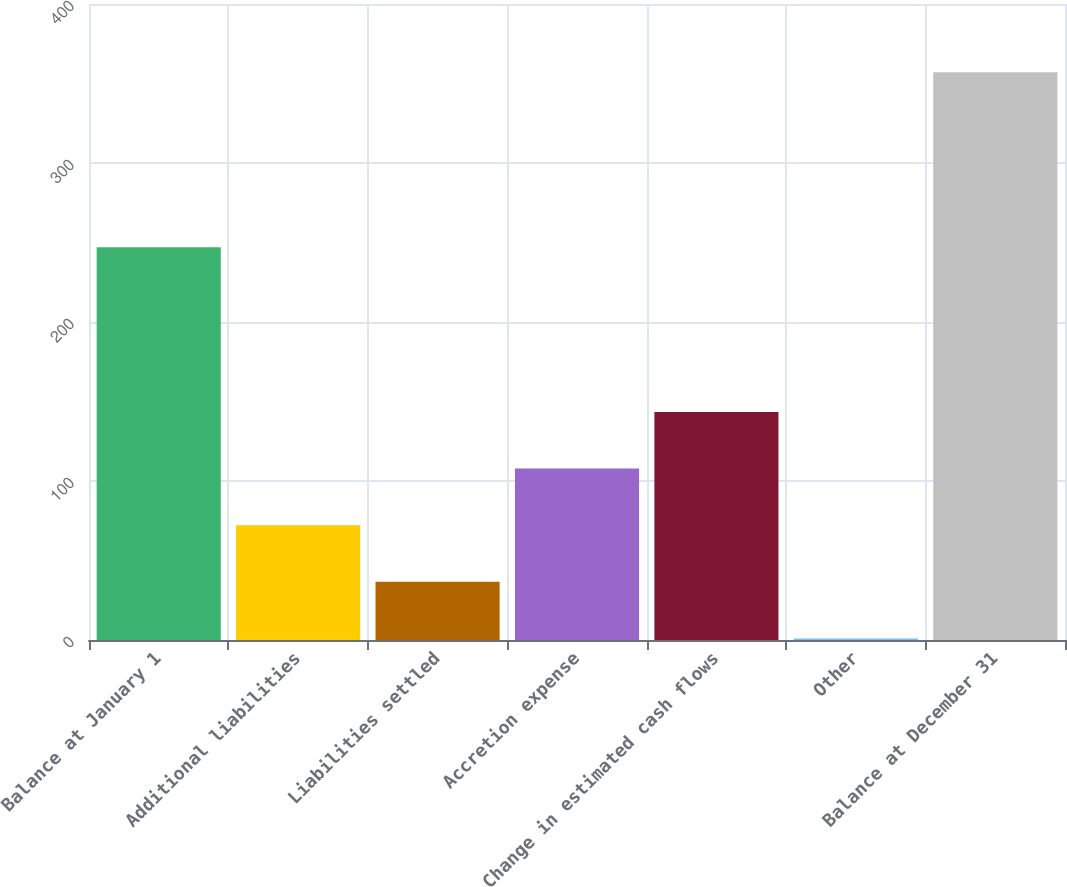Convert chart. <chart><loc_0><loc_0><loc_500><loc_500><bar_chart><fcel>Balance at January 1<fcel>Additional liabilities<fcel>Liabilities settled<fcel>Accretion expense<fcel>Change in estimated cash flows<fcel>Other<fcel>Balance at December 31<nl><fcel>247<fcel>72.2<fcel>36.6<fcel>107.8<fcel>143.4<fcel>1<fcel>357<nl></chart> 